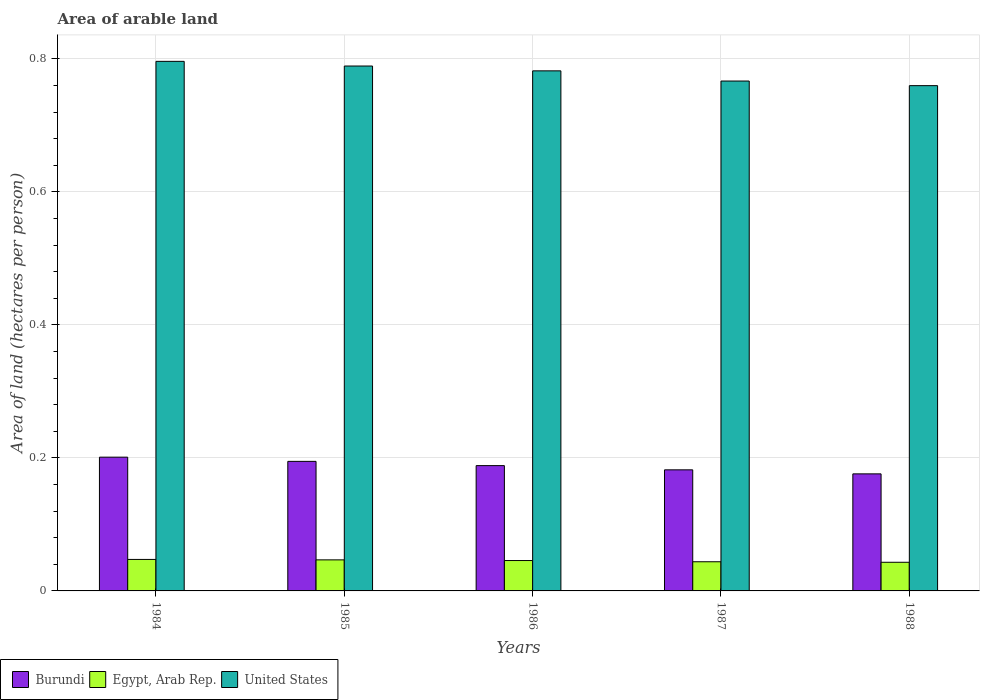How many different coloured bars are there?
Give a very brief answer. 3. What is the label of the 2nd group of bars from the left?
Make the answer very short. 1985. In how many cases, is the number of bars for a given year not equal to the number of legend labels?
Your answer should be very brief. 0. What is the total arable land in Egypt, Arab Rep. in 1985?
Your answer should be compact. 0.05. Across all years, what is the maximum total arable land in United States?
Provide a succinct answer. 0.8. Across all years, what is the minimum total arable land in Egypt, Arab Rep.?
Ensure brevity in your answer.  0.04. What is the total total arable land in Egypt, Arab Rep. in the graph?
Your response must be concise. 0.23. What is the difference between the total arable land in Egypt, Arab Rep. in 1985 and that in 1988?
Your answer should be very brief. 0. What is the difference between the total arable land in Egypt, Arab Rep. in 1985 and the total arable land in United States in 1984?
Offer a terse response. -0.75. What is the average total arable land in United States per year?
Offer a very short reply. 0.78. In the year 1987, what is the difference between the total arable land in United States and total arable land in Egypt, Arab Rep.?
Provide a short and direct response. 0.72. In how many years, is the total arable land in Egypt, Arab Rep. greater than 0.04 hectares per person?
Make the answer very short. 5. What is the ratio of the total arable land in United States in 1984 to that in 1985?
Give a very brief answer. 1.01. Is the total arable land in United States in 1985 less than that in 1986?
Ensure brevity in your answer.  No. What is the difference between the highest and the second highest total arable land in Egypt, Arab Rep.?
Provide a short and direct response. 0. What is the difference between the highest and the lowest total arable land in Egypt, Arab Rep.?
Offer a very short reply. 0. What does the 2nd bar from the left in 1984 represents?
Ensure brevity in your answer.  Egypt, Arab Rep. What does the 3rd bar from the right in 1987 represents?
Keep it short and to the point. Burundi. Is it the case that in every year, the sum of the total arable land in Egypt, Arab Rep. and total arable land in Burundi is greater than the total arable land in United States?
Offer a very short reply. No. How many bars are there?
Your response must be concise. 15. What is the difference between two consecutive major ticks on the Y-axis?
Ensure brevity in your answer.  0.2. Are the values on the major ticks of Y-axis written in scientific E-notation?
Provide a short and direct response. No. Does the graph contain any zero values?
Your answer should be compact. No. How many legend labels are there?
Offer a very short reply. 3. How are the legend labels stacked?
Ensure brevity in your answer.  Horizontal. What is the title of the graph?
Your answer should be compact. Area of arable land. What is the label or title of the X-axis?
Make the answer very short. Years. What is the label or title of the Y-axis?
Keep it short and to the point. Area of land (hectares per person). What is the Area of land (hectares per person) in Burundi in 1984?
Make the answer very short. 0.2. What is the Area of land (hectares per person) of Egypt, Arab Rep. in 1984?
Your answer should be compact. 0.05. What is the Area of land (hectares per person) of United States in 1984?
Keep it short and to the point. 0.8. What is the Area of land (hectares per person) of Burundi in 1985?
Your answer should be very brief. 0.19. What is the Area of land (hectares per person) of Egypt, Arab Rep. in 1985?
Your answer should be compact. 0.05. What is the Area of land (hectares per person) in United States in 1985?
Your response must be concise. 0.79. What is the Area of land (hectares per person) in Burundi in 1986?
Offer a very short reply. 0.19. What is the Area of land (hectares per person) of Egypt, Arab Rep. in 1986?
Offer a terse response. 0.05. What is the Area of land (hectares per person) in United States in 1986?
Offer a terse response. 0.78. What is the Area of land (hectares per person) in Burundi in 1987?
Make the answer very short. 0.18. What is the Area of land (hectares per person) in Egypt, Arab Rep. in 1987?
Your answer should be very brief. 0.04. What is the Area of land (hectares per person) of United States in 1987?
Provide a short and direct response. 0.77. What is the Area of land (hectares per person) in Burundi in 1988?
Give a very brief answer. 0.18. What is the Area of land (hectares per person) of Egypt, Arab Rep. in 1988?
Provide a short and direct response. 0.04. What is the Area of land (hectares per person) of United States in 1988?
Your response must be concise. 0.76. Across all years, what is the maximum Area of land (hectares per person) of Burundi?
Provide a succinct answer. 0.2. Across all years, what is the maximum Area of land (hectares per person) in Egypt, Arab Rep.?
Your answer should be very brief. 0.05. Across all years, what is the maximum Area of land (hectares per person) in United States?
Your answer should be very brief. 0.8. Across all years, what is the minimum Area of land (hectares per person) in Burundi?
Give a very brief answer. 0.18. Across all years, what is the minimum Area of land (hectares per person) in Egypt, Arab Rep.?
Give a very brief answer. 0.04. Across all years, what is the minimum Area of land (hectares per person) of United States?
Your answer should be compact. 0.76. What is the total Area of land (hectares per person) in Burundi in the graph?
Make the answer very short. 0.94. What is the total Area of land (hectares per person) in Egypt, Arab Rep. in the graph?
Ensure brevity in your answer.  0.23. What is the total Area of land (hectares per person) of United States in the graph?
Make the answer very short. 3.89. What is the difference between the Area of land (hectares per person) in Burundi in 1984 and that in 1985?
Keep it short and to the point. 0.01. What is the difference between the Area of land (hectares per person) in Egypt, Arab Rep. in 1984 and that in 1985?
Offer a terse response. 0. What is the difference between the Area of land (hectares per person) of United States in 1984 and that in 1985?
Provide a succinct answer. 0.01. What is the difference between the Area of land (hectares per person) of Burundi in 1984 and that in 1986?
Keep it short and to the point. 0.01. What is the difference between the Area of land (hectares per person) of Egypt, Arab Rep. in 1984 and that in 1986?
Provide a succinct answer. 0. What is the difference between the Area of land (hectares per person) in United States in 1984 and that in 1986?
Ensure brevity in your answer.  0.01. What is the difference between the Area of land (hectares per person) in Burundi in 1984 and that in 1987?
Offer a very short reply. 0.02. What is the difference between the Area of land (hectares per person) of Egypt, Arab Rep. in 1984 and that in 1987?
Provide a short and direct response. 0. What is the difference between the Area of land (hectares per person) of United States in 1984 and that in 1987?
Make the answer very short. 0.03. What is the difference between the Area of land (hectares per person) in Burundi in 1984 and that in 1988?
Give a very brief answer. 0.03. What is the difference between the Area of land (hectares per person) in Egypt, Arab Rep. in 1984 and that in 1988?
Your response must be concise. 0. What is the difference between the Area of land (hectares per person) of United States in 1984 and that in 1988?
Give a very brief answer. 0.04. What is the difference between the Area of land (hectares per person) in Burundi in 1985 and that in 1986?
Provide a succinct answer. 0.01. What is the difference between the Area of land (hectares per person) of United States in 1985 and that in 1986?
Ensure brevity in your answer.  0.01. What is the difference between the Area of land (hectares per person) of Burundi in 1985 and that in 1987?
Make the answer very short. 0.01. What is the difference between the Area of land (hectares per person) of Egypt, Arab Rep. in 1985 and that in 1987?
Your answer should be very brief. 0. What is the difference between the Area of land (hectares per person) in United States in 1985 and that in 1987?
Your response must be concise. 0.02. What is the difference between the Area of land (hectares per person) in Burundi in 1985 and that in 1988?
Your answer should be very brief. 0.02. What is the difference between the Area of land (hectares per person) in Egypt, Arab Rep. in 1985 and that in 1988?
Provide a short and direct response. 0. What is the difference between the Area of land (hectares per person) of United States in 1985 and that in 1988?
Make the answer very short. 0.03. What is the difference between the Area of land (hectares per person) in Burundi in 1986 and that in 1987?
Provide a short and direct response. 0.01. What is the difference between the Area of land (hectares per person) of Egypt, Arab Rep. in 1986 and that in 1987?
Provide a short and direct response. 0. What is the difference between the Area of land (hectares per person) of United States in 1986 and that in 1987?
Keep it short and to the point. 0.02. What is the difference between the Area of land (hectares per person) in Burundi in 1986 and that in 1988?
Ensure brevity in your answer.  0.01. What is the difference between the Area of land (hectares per person) of Egypt, Arab Rep. in 1986 and that in 1988?
Ensure brevity in your answer.  0. What is the difference between the Area of land (hectares per person) of United States in 1986 and that in 1988?
Make the answer very short. 0.02. What is the difference between the Area of land (hectares per person) in Burundi in 1987 and that in 1988?
Provide a succinct answer. 0.01. What is the difference between the Area of land (hectares per person) of Egypt, Arab Rep. in 1987 and that in 1988?
Offer a terse response. 0. What is the difference between the Area of land (hectares per person) of United States in 1987 and that in 1988?
Provide a succinct answer. 0.01. What is the difference between the Area of land (hectares per person) of Burundi in 1984 and the Area of land (hectares per person) of Egypt, Arab Rep. in 1985?
Give a very brief answer. 0.15. What is the difference between the Area of land (hectares per person) in Burundi in 1984 and the Area of land (hectares per person) in United States in 1985?
Ensure brevity in your answer.  -0.59. What is the difference between the Area of land (hectares per person) of Egypt, Arab Rep. in 1984 and the Area of land (hectares per person) of United States in 1985?
Offer a very short reply. -0.74. What is the difference between the Area of land (hectares per person) in Burundi in 1984 and the Area of land (hectares per person) in Egypt, Arab Rep. in 1986?
Offer a very short reply. 0.16. What is the difference between the Area of land (hectares per person) in Burundi in 1984 and the Area of land (hectares per person) in United States in 1986?
Provide a succinct answer. -0.58. What is the difference between the Area of land (hectares per person) in Egypt, Arab Rep. in 1984 and the Area of land (hectares per person) in United States in 1986?
Your answer should be compact. -0.73. What is the difference between the Area of land (hectares per person) in Burundi in 1984 and the Area of land (hectares per person) in Egypt, Arab Rep. in 1987?
Your answer should be compact. 0.16. What is the difference between the Area of land (hectares per person) in Burundi in 1984 and the Area of land (hectares per person) in United States in 1987?
Give a very brief answer. -0.57. What is the difference between the Area of land (hectares per person) in Egypt, Arab Rep. in 1984 and the Area of land (hectares per person) in United States in 1987?
Make the answer very short. -0.72. What is the difference between the Area of land (hectares per person) in Burundi in 1984 and the Area of land (hectares per person) in Egypt, Arab Rep. in 1988?
Make the answer very short. 0.16. What is the difference between the Area of land (hectares per person) of Burundi in 1984 and the Area of land (hectares per person) of United States in 1988?
Make the answer very short. -0.56. What is the difference between the Area of land (hectares per person) in Egypt, Arab Rep. in 1984 and the Area of land (hectares per person) in United States in 1988?
Your response must be concise. -0.71. What is the difference between the Area of land (hectares per person) of Burundi in 1985 and the Area of land (hectares per person) of Egypt, Arab Rep. in 1986?
Offer a terse response. 0.15. What is the difference between the Area of land (hectares per person) in Burundi in 1985 and the Area of land (hectares per person) in United States in 1986?
Ensure brevity in your answer.  -0.59. What is the difference between the Area of land (hectares per person) in Egypt, Arab Rep. in 1985 and the Area of land (hectares per person) in United States in 1986?
Ensure brevity in your answer.  -0.74. What is the difference between the Area of land (hectares per person) in Burundi in 1985 and the Area of land (hectares per person) in Egypt, Arab Rep. in 1987?
Make the answer very short. 0.15. What is the difference between the Area of land (hectares per person) in Burundi in 1985 and the Area of land (hectares per person) in United States in 1987?
Ensure brevity in your answer.  -0.57. What is the difference between the Area of land (hectares per person) of Egypt, Arab Rep. in 1985 and the Area of land (hectares per person) of United States in 1987?
Offer a very short reply. -0.72. What is the difference between the Area of land (hectares per person) of Burundi in 1985 and the Area of land (hectares per person) of Egypt, Arab Rep. in 1988?
Offer a terse response. 0.15. What is the difference between the Area of land (hectares per person) of Burundi in 1985 and the Area of land (hectares per person) of United States in 1988?
Your answer should be very brief. -0.56. What is the difference between the Area of land (hectares per person) in Egypt, Arab Rep. in 1985 and the Area of land (hectares per person) in United States in 1988?
Your response must be concise. -0.71. What is the difference between the Area of land (hectares per person) in Burundi in 1986 and the Area of land (hectares per person) in Egypt, Arab Rep. in 1987?
Keep it short and to the point. 0.14. What is the difference between the Area of land (hectares per person) of Burundi in 1986 and the Area of land (hectares per person) of United States in 1987?
Your answer should be very brief. -0.58. What is the difference between the Area of land (hectares per person) in Egypt, Arab Rep. in 1986 and the Area of land (hectares per person) in United States in 1987?
Your answer should be compact. -0.72. What is the difference between the Area of land (hectares per person) in Burundi in 1986 and the Area of land (hectares per person) in Egypt, Arab Rep. in 1988?
Offer a very short reply. 0.15. What is the difference between the Area of land (hectares per person) in Burundi in 1986 and the Area of land (hectares per person) in United States in 1988?
Provide a short and direct response. -0.57. What is the difference between the Area of land (hectares per person) of Egypt, Arab Rep. in 1986 and the Area of land (hectares per person) of United States in 1988?
Your answer should be compact. -0.71. What is the difference between the Area of land (hectares per person) in Burundi in 1987 and the Area of land (hectares per person) in Egypt, Arab Rep. in 1988?
Your response must be concise. 0.14. What is the difference between the Area of land (hectares per person) of Burundi in 1987 and the Area of land (hectares per person) of United States in 1988?
Your response must be concise. -0.58. What is the difference between the Area of land (hectares per person) of Egypt, Arab Rep. in 1987 and the Area of land (hectares per person) of United States in 1988?
Give a very brief answer. -0.72. What is the average Area of land (hectares per person) in Burundi per year?
Your answer should be very brief. 0.19. What is the average Area of land (hectares per person) in Egypt, Arab Rep. per year?
Ensure brevity in your answer.  0.05. What is the average Area of land (hectares per person) of United States per year?
Make the answer very short. 0.78. In the year 1984, what is the difference between the Area of land (hectares per person) in Burundi and Area of land (hectares per person) in Egypt, Arab Rep.?
Give a very brief answer. 0.15. In the year 1984, what is the difference between the Area of land (hectares per person) of Burundi and Area of land (hectares per person) of United States?
Ensure brevity in your answer.  -0.6. In the year 1984, what is the difference between the Area of land (hectares per person) in Egypt, Arab Rep. and Area of land (hectares per person) in United States?
Provide a short and direct response. -0.75. In the year 1985, what is the difference between the Area of land (hectares per person) in Burundi and Area of land (hectares per person) in Egypt, Arab Rep.?
Your answer should be compact. 0.15. In the year 1985, what is the difference between the Area of land (hectares per person) in Burundi and Area of land (hectares per person) in United States?
Your response must be concise. -0.59. In the year 1985, what is the difference between the Area of land (hectares per person) of Egypt, Arab Rep. and Area of land (hectares per person) of United States?
Your response must be concise. -0.74. In the year 1986, what is the difference between the Area of land (hectares per person) of Burundi and Area of land (hectares per person) of Egypt, Arab Rep.?
Offer a very short reply. 0.14. In the year 1986, what is the difference between the Area of land (hectares per person) of Burundi and Area of land (hectares per person) of United States?
Your answer should be compact. -0.59. In the year 1986, what is the difference between the Area of land (hectares per person) in Egypt, Arab Rep. and Area of land (hectares per person) in United States?
Offer a very short reply. -0.74. In the year 1987, what is the difference between the Area of land (hectares per person) of Burundi and Area of land (hectares per person) of Egypt, Arab Rep.?
Your response must be concise. 0.14. In the year 1987, what is the difference between the Area of land (hectares per person) in Burundi and Area of land (hectares per person) in United States?
Your answer should be compact. -0.58. In the year 1987, what is the difference between the Area of land (hectares per person) of Egypt, Arab Rep. and Area of land (hectares per person) of United States?
Your answer should be very brief. -0.72. In the year 1988, what is the difference between the Area of land (hectares per person) in Burundi and Area of land (hectares per person) in Egypt, Arab Rep.?
Your answer should be very brief. 0.13. In the year 1988, what is the difference between the Area of land (hectares per person) in Burundi and Area of land (hectares per person) in United States?
Your answer should be compact. -0.58. In the year 1988, what is the difference between the Area of land (hectares per person) of Egypt, Arab Rep. and Area of land (hectares per person) of United States?
Provide a short and direct response. -0.72. What is the ratio of the Area of land (hectares per person) of Burundi in 1984 to that in 1985?
Your answer should be compact. 1.03. What is the ratio of the Area of land (hectares per person) in United States in 1984 to that in 1985?
Your response must be concise. 1.01. What is the ratio of the Area of land (hectares per person) in Burundi in 1984 to that in 1986?
Your answer should be compact. 1.07. What is the ratio of the Area of land (hectares per person) in Egypt, Arab Rep. in 1984 to that in 1986?
Your response must be concise. 1.04. What is the ratio of the Area of land (hectares per person) in United States in 1984 to that in 1986?
Your answer should be compact. 1.02. What is the ratio of the Area of land (hectares per person) in Burundi in 1984 to that in 1987?
Provide a short and direct response. 1.1. What is the ratio of the Area of land (hectares per person) of Egypt, Arab Rep. in 1984 to that in 1987?
Keep it short and to the point. 1.08. What is the ratio of the Area of land (hectares per person) of United States in 1984 to that in 1987?
Offer a very short reply. 1.04. What is the ratio of the Area of land (hectares per person) in Burundi in 1984 to that in 1988?
Offer a very short reply. 1.14. What is the ratio of the Area of land (hectares per person) in Egypt, Arab Rep. in 1984 to that in 1988?
Your response must be concise. 1.1. What is the ratio of the Area of land (hectares per person) in United States in 1984 to that in 1988?
Offer a terse response. 1.05. What is the ratio of the Area of land (hectares per person) in Burundi in 1985 to that in 1986?
Offer a terse response. 1.03. What is the ratio of the Area of land (hectares per person) of Egypt, Arab Rep. in 1985 to that in 1986?
Your response must be concise. 1.02. What is the ratio of the Area of land (hectares per person) of United States in 1985 to that in 1986?
Make the answer very short. 1.01. What is the ratio of the Area of land (hectares per person) of Burundi in 1985 to that in 1987?
Give a very brief answer. 1.07. What is the ratio of the Area of land (hectares per person) in Egypt, Arab Rep. in 1985 to that in 1987?
Provide a short and direct response. 1.06. What is the ratio of the Area of land (hectares per person) in United States in 1985 to that in 1987?
Your response must be concise. 1.03. What is the ratio of the Area of land (hectares per person) of Burundi in 1985 to that in 1988?
Your answer should be compact. 1.11. What is the ratio of the Area of land (hectares per person) of Egypt, Arab Rep. in 1985 to that in 1988?
Your answer should be compact. 1.08. What is the ratio of the Area of land (hectares per person) of United States in 1985 to that in 1988?
Offer a very short reply. 1.04. What is the ratio of the Area of land (hectares per person) of Burundi in 1986 to that in 1987?
Your answer should be very brief. 1.03. What is the ratio of the Area of land (hectares per person) of Egypt, Arab Rep. in 1986 to that in 1987?
Keep it short and to the point. 1.04. What is the ratio of the Area of land (hectares per person) in Burundi in 1986 to that in 1988?
Make the answer very short. 1.07. What is the ratio of the Area of land (hectares per person) in Egypt, Arab Rep. in 1986 to that in 1988?
Your answer should be very brief. 1.06. What is the ratio of the Area of land (hectares per person) of United States in 1986 to that in 1988?
Give a very brief answer. 1.03. What is the ratio of the Area of land (hectares per person) in Burundi in 1987 to that in 1988?
Keep it short and to the point. 1.03. What is the ratio of the Area of land (hectares per person) in Egypt, Arab Rep. in 1987 to that in 1988?
Your answer should be very brief. 1.02. What is the ratio of the Area of land (hectares per person) of United States in 1987 to that in 1988?
Your answer should be very brief. 1.01. What is the difference between the highest and the second highest Area of land (hectares per person) of Burundi?
Your answer should be compact. 0.01. What is the difference between the highest and the second highest Area of land (hectares per person) of Egypt, Arab Rep.?
Your response must be concise. 0. What is the difference between the highest and the second highest Area of land (hectares per person) of United States?
Your answer should be compact. 0.01. What is the difference between the highest and the lowest Area of land (hectares per person) in Burundi?
Your response must be concise. 0.03. What is the difference between the highest and the lowest Area of land (hectares per person) in Egypt, Arab Rep.?
Ensure brevity in your answer.  0. What is the difference between the highest and the lowest Area of land (hectares per person) in United States?
Your answer should be very brief. 0.04. 